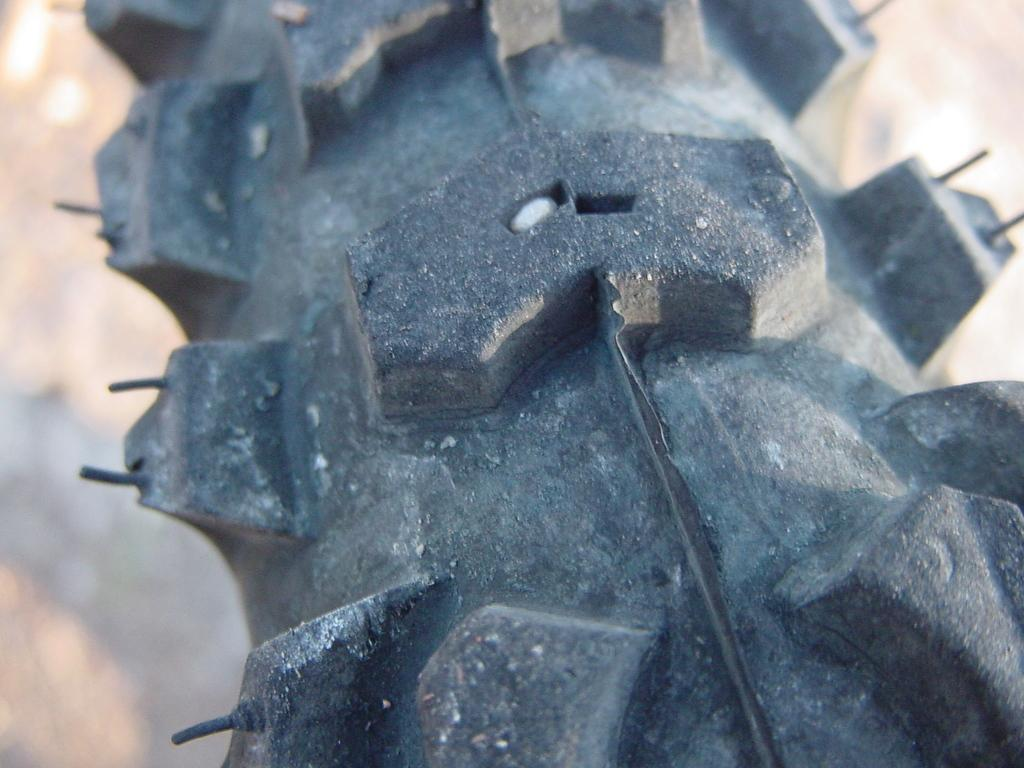What object in the image resembles a tire? There is an object that looks like a tire in the image. Can you describe the background of the image? The background of the image is blurry. Can you hear the ear in the image? There is no ear present in the image, so it cannot be heard. 